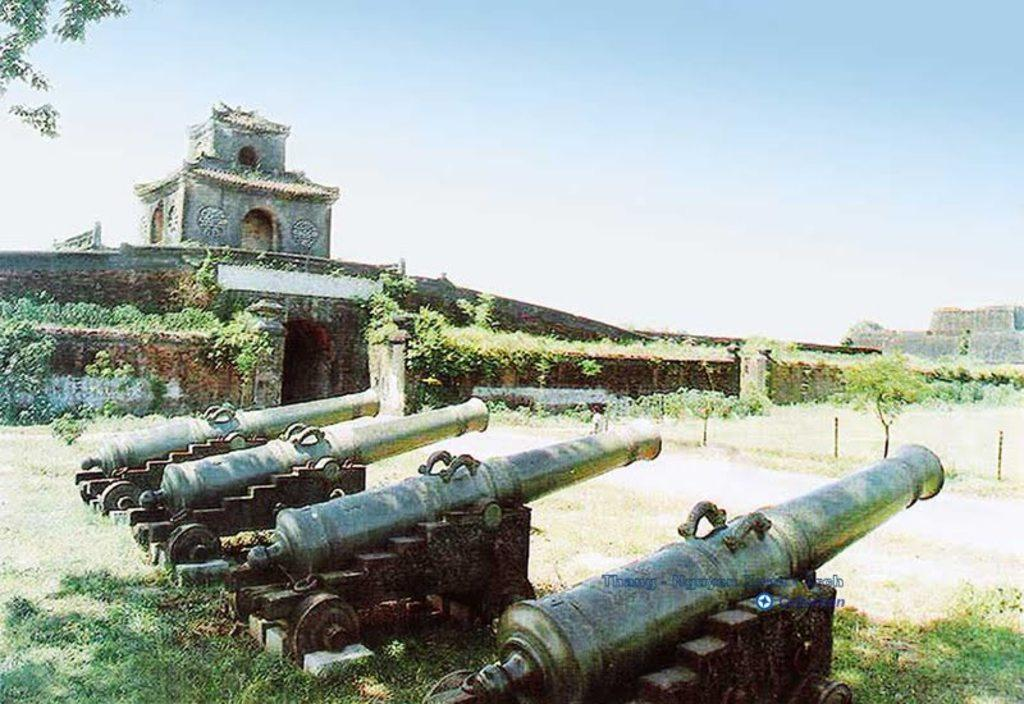How many cannons are visible in the image? There are four cannons in the image. What can be seen in the background of the image? There are trees and a building in the background of the image. What is the color of the trees in the image? The trees are green in color. What is the color of the sky in the image? The sky is blue and white in color. How many boys are playing on the edge of the cloud in the image? There are no boys or clouds present in the image; it features four cannons, trees, a building, and a blue and white sky. 